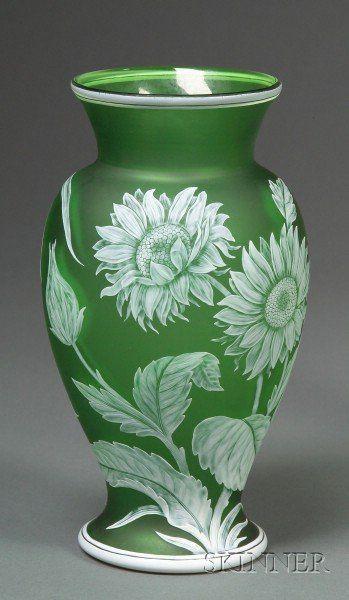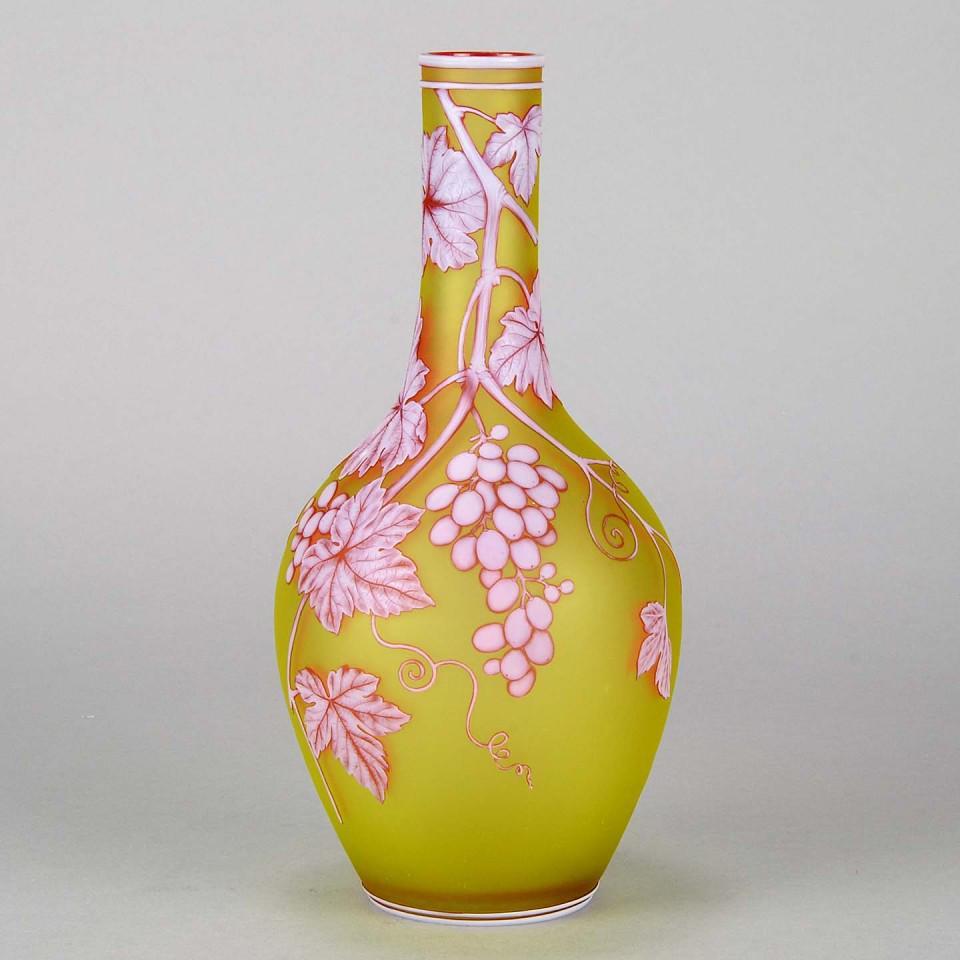The first image is the image on the left, the second image is the image on the right. For the images displayed, is the sentence "There is a vase that is predominantly green and a vase that is predominantly yellow." factually correct? Answer yes or no. Yes. The first image is the image on the left, the second image is the image on the right. For the images shown, is this caption "The vases have a floral pattern in both images." true? Answer yes or no. Yes. 